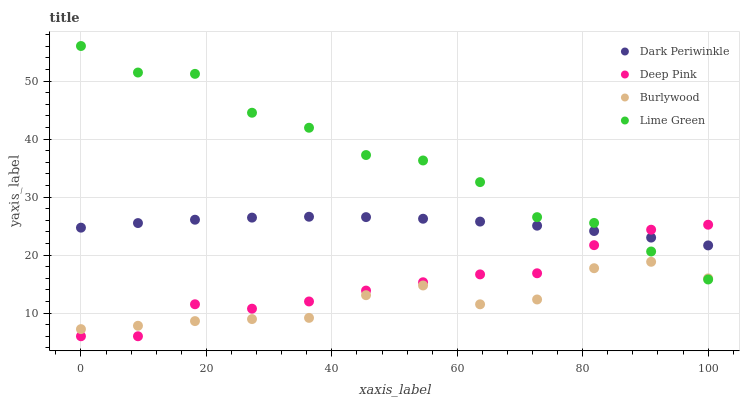Does Burlywood have the minimum area under the curve?
Answer yes or no. Yes. Does Lime Green have the maximum area under the curve?
Answer yes or no. Yes. Does Deep Pink have the minimum area under the curve?
Answer yes or no. No. Does Deep Pink have the maximum area under the curve?
Answer yes or no. No. Is Dark Periwinkle the smoothest?
Answer yes or no. Yes. Is Lime Green the roughest?
Answer yes or no. Yes. Is Deep Pink the smoothest?
Answer yes or no. No. Is Deep Pink the roughest?
Answer yes or no. No. Does Deep Pink have the lowest value?
Answer yes or no. Yes. Does Lime Green have the lowest value?
Answer yes or no. No. Does Lime Green have the highest value?
Answer yes or no. Yes. Does Deep Pink have the highest value?
Answer yes or no. No. Is Burlywood less than Dark Periwinkle?
Answer yes or no. Yes. Is Dark Periwinkle greater than Burlywood?
Answer yes or no. Yes. Does Deep Pink intersect Lime Green?
Answer yes or no. Yes. Is Deep Pink less than Lime Green?
Answer yes or no. No. Is Deep Pink greater than Lime Green?
Answer yes or no. No. Does Burlywood intersect Dark Periwinkle?
Answer yes or no. No. 